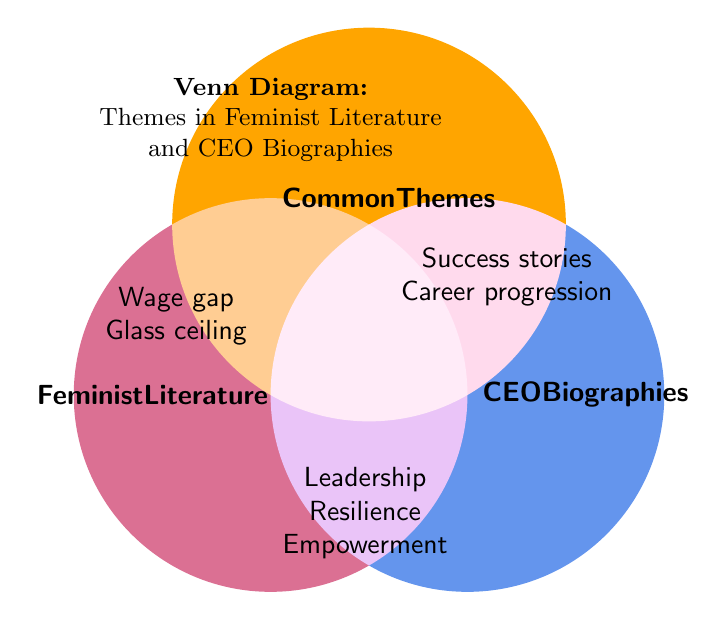What are the three main areas covered in the Venn Diagram? The Venn Diagram highlights three main areas: "Feminist Literature," "Common Themes," and "CEO Biographies." These areas are visually represented by three overlapping circles.
Answer: Feminist Literature, Common Themes, CEO Biographies What specific themes are unique to "Feminist Literature"? Unique themes to "Feminist Literature" are those present only in the section labeled "Feminist Literature" and not overlapping with "Common Themes" or "CEO Biographies." These themes include "Wage gap," "Glass ceiling," "Work-life balance," "Reproductive rights," "Gender stereotypes," "Sexual harassment," and "Body autonomy."
Answer: Wage gap, Glass ceiling, Work-life balance, Reproductive rights, Gender stereotypes, Sexual harassment, Body autonomy Which common theme suggests an attribute crucial for overcoming hardships? The common theme indicating an attribute crucial for overcoming hardships is "Resilience." This theme is part of the "Common Themes" area, suggesting it is important in both feminist literature and CEO biographies.
Answer: Resilience Are there any themes associated with "CEO Biographies" that also emphasize innovation? Yes, "Innovation" is a theme that is specifically associated with "CEO Biographies."
Answer: Innovation How many themes are exclusively listed under "Common Themes"? Count the unique themes in the "Common Themes" section to find the number. The themes listed are "Leadership," "Resilience," and "Empowerment."
Answer: Three (3) Which themes do "Feminist Literature" and "CEO Biographies" share? By examining the overlapping area between "Common Themes" and the themes presented in both "Feminist Literature" and "CEO Biographies," the shared themes are: "Leadership," "Resilience," and "Empowerment."
Answer: Leadership, Resilience, Empowerment Which theme involves mentorship and where is it located? The theme involving mentorship is "Mentorship." It is located within the "CEO Biographies" section.
Answer: Mentorship What is the relationship between "Confidence" and "Empowerment" in the Venn Diagram? "Confidence" is located under "CEO Biographies," whereas "Empowerment" is a theme within "Common Themes." Hence, "Empowerment" is a shared theme between feminist literature and CEO biographies, suggesting both value this attribute, while "Confidence" is seen primarily in CEO narratives.
Answer: "Empowerment" is a shared theme; "Confidence" is specific to CEO Biographies How does the theme of "Risk-taking" align with the categories presented? "Risk-taking" appears under the "CEO Biographies" section, indicating that it is a theme prevalent in the narratives and stories of CEO success and career progression, rather than in feminist literature or the common themes shared between both domains.
Answer: CEO Biographies Which category uniquely addresses financial skills, and what theme represents it? The category "CEO Biographies" uniquely addresses financial skills through the theme of "Financial acumen." This theme is not found in "Feminist Literature" or "Common Themes."
Answer: CEO Biographies, Financial acumen 